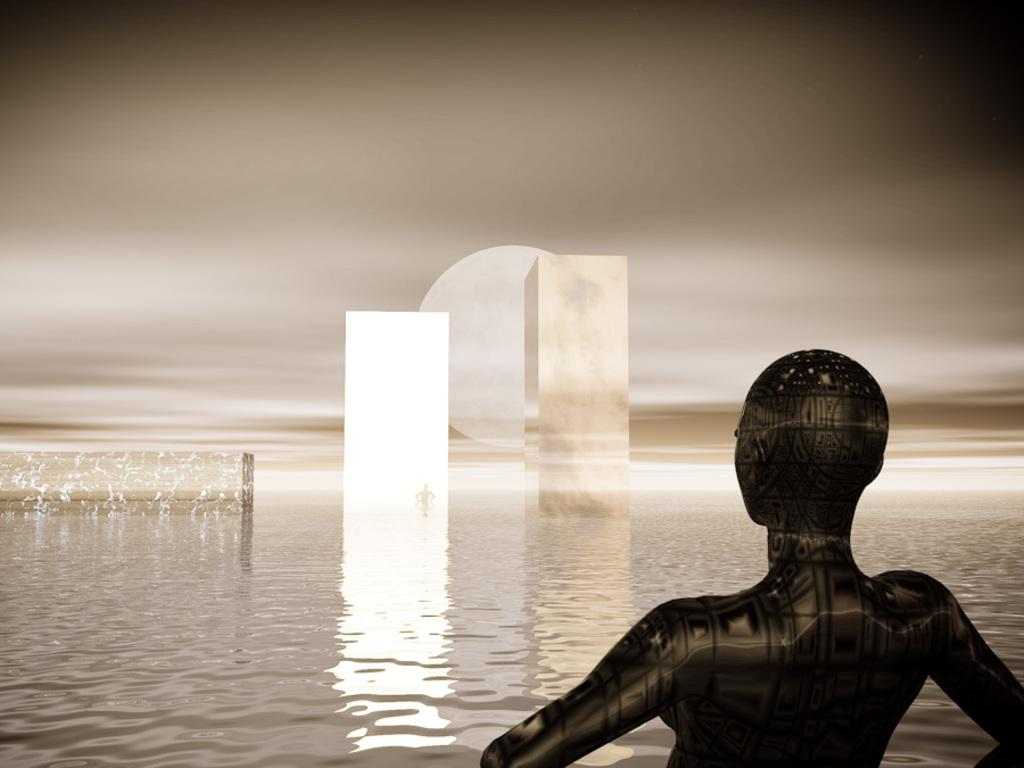What type of image is being described? The image is animated. Can you describe the main subject in the image? There is a person in the image. What else can be seen in the image besides the person? There are structures and water in the image. What is visible at the top of the image? The sky is visible at the top of the image. What type of mark does the wind leave on the person's face in the image? There is no wind or mark on the person's face in the image; it is an animated image without any indication of wind or marks. Can you tell me how many chess pieces are visible in the image? There are no chess pieces present in the image. 